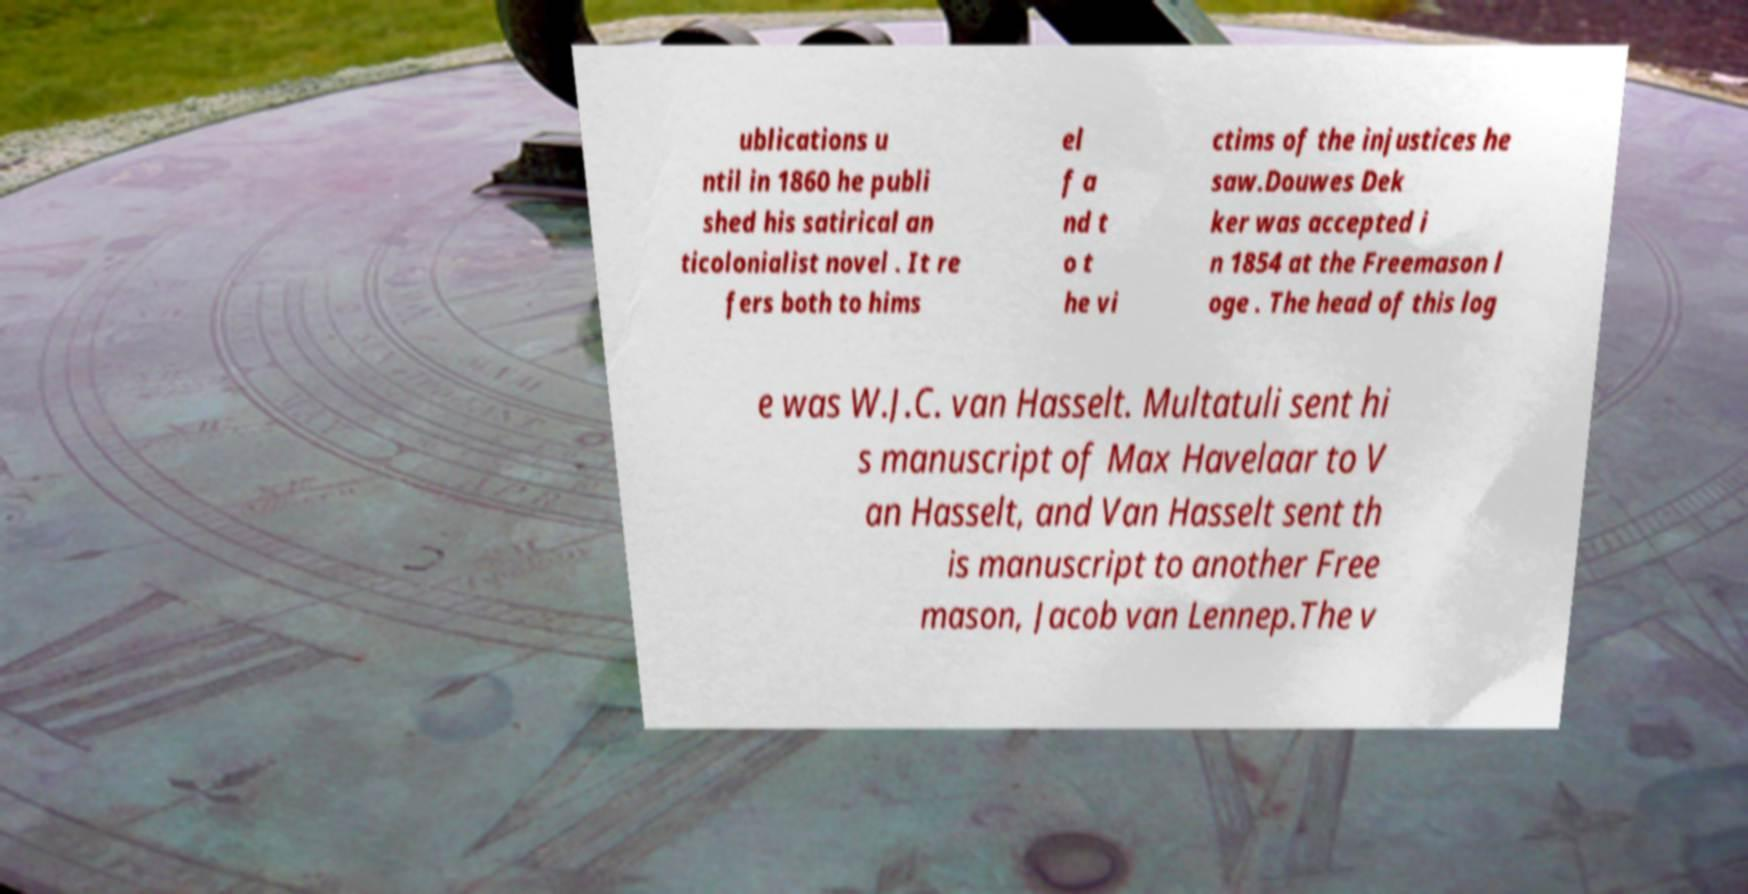Please identify and transcribe the text found in this image. ublications u ntil in 1860 he publi shed his satirical an ticolonialist novel . It re fers both to hims el f a nd t o t he vi ctims of the injustices he saw.Douwes Dek ker was accepted i n 1854 at the Freemason l oge . The head of this log e was W.J.C. van Hasselt. Multatuli sent hi s manuscript of Max Havelaar to V an Hasselt, and Van Hasselt sent th is manuscript to another Free mason, Jacob van Lennep.The v 